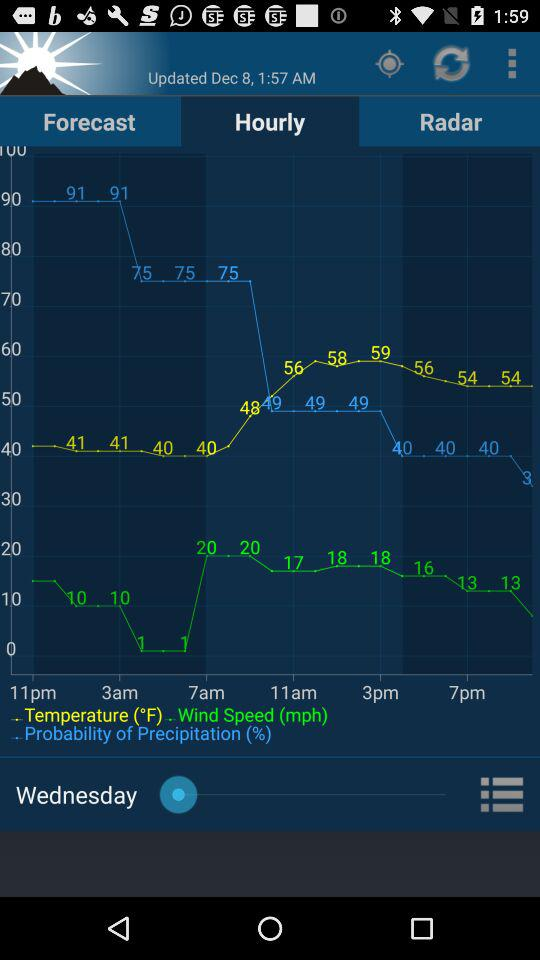What is the given day? The given day is Wednesday. 